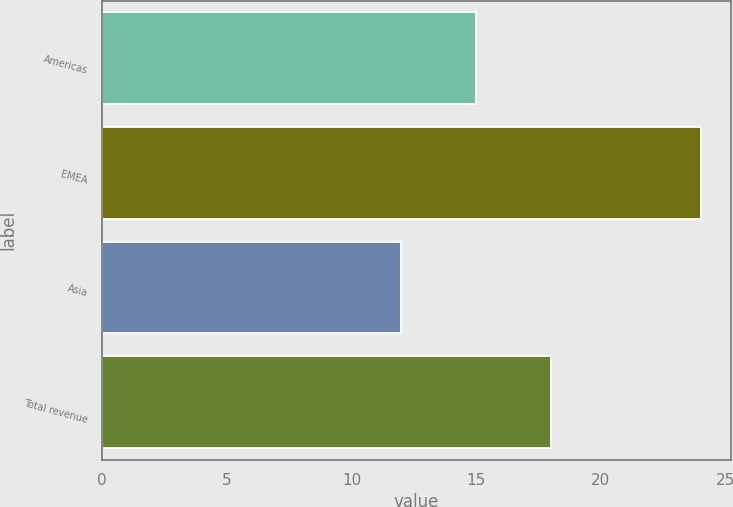Convert chart to OTSL. <chart><loc_0><loc_0><loc_500><loc_500><bar_chart><fcel>Americas<fcel>EMEA<fcel>Asia<fcel>Total revenue<nl><fcel>15<fcel>24<fcel>12<fcel>18<nl></chart> 